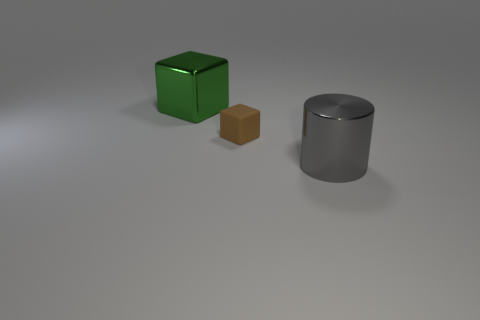Add 3 big cyan rubber balls. How many objects exist? 6 Subtract all cubes. How many objects are left? 1 Add 2 big green shiny blocks. How many big green shiny blocks are left? 3 Add 3 small blue rubber cylinders. How many small blue rubber cylinders exist? 3 Subtract 0 yellow spheres. How many objects are left? 3 Subtract all big brown cylinders. Subtract all large cylinders. How many objects are left? 2 